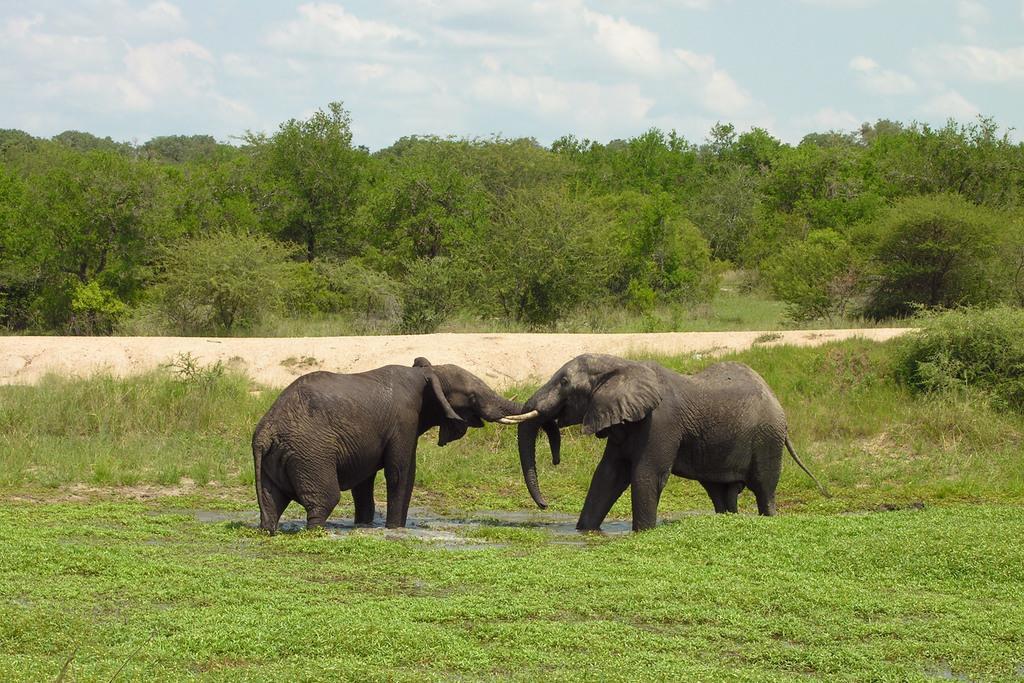Can you describe this image briefly? In this image I can see the water, two elephants which are black in color are standing in the water, some grass and in the background I can see the ground, few trees which are green in color and the sky. 